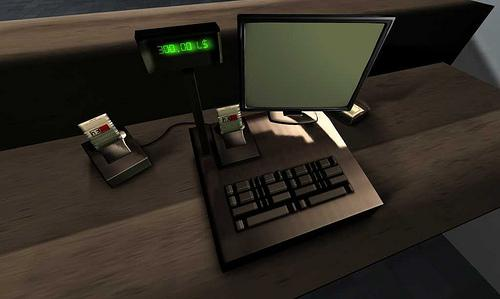Question: how was this picture taken?
Choices:
A. It was drawn.
B. With a camera.
C. With a mirror.
D. With a toothbrush.
Answer with the letter. Answer: B Question: what is the object to the right.with a screen?
Choices:
A. A television.
B. A window.
C. A furnace.
D. A computer monitor.
Answer with the letter. Answer: D Question: what is the wooden item displayed in the photo?
Choices:
A. A table.
B. A couch.
C. A desk.
D. A bench.
Answer with the letter. Answer: C Question: who captured this photograph?
Choices:
A. An actor.
B. A photographer.
C. A director.
D. A painter.
Answer with the letter. Answer: B Question: what are the objects displayed in the background?
Choices:
A. Pianos.
B. Electronics.
C. Stuffed animals.
D. Vases.
Answer with the letter. Answer: B Question: where was this picture taken?
Choices:
A. At a Game Stop.
B. On a wood table.
C. On the highway.
D. In Central Park.
Answer with the letter. Answer: B 